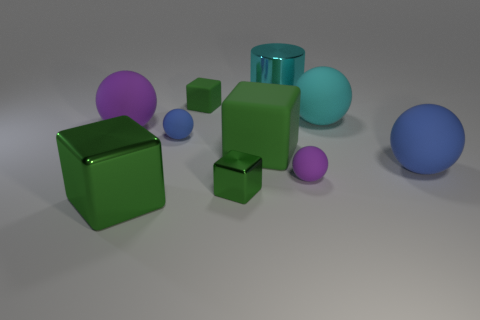What time of day does this scene look like, considering the lighting and shadows? The scene doesn't provide explicit cues about the actual time of day, as it appears to be artificially lit with a neutral, diffuse light source that creates soft shadows. This type of lighting is typical of an indoor setting or a studio environment where the light is controlled, and natural light patterns such as those from the sun are not present. 